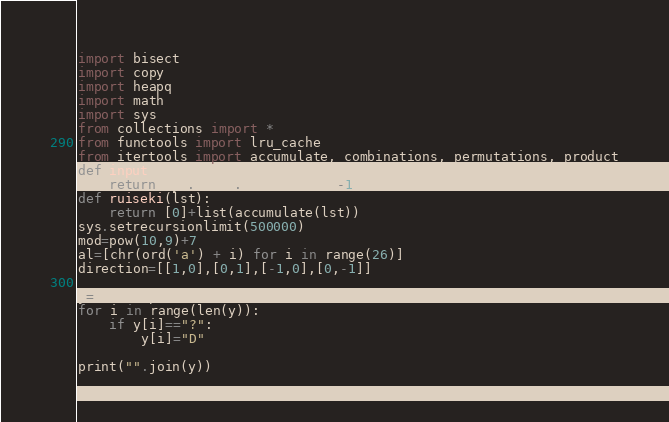<code> <loc_0><loc_0><loc_500><loc_500><_Python_>import bisect
import copy
import heapq
import math
import sys
from collections import *
from functools import lru_cache
from itertools import accumulate, combinations, permutations, product
def input():
    return sys.stdin.readline()[:-1]
def ruiseki(lst):
    return [0]+list(accumulate(lst))
sys.setrecursionlimit(500000)
mod=pow(10,9)+7
al=[chr(ord('a') + i) for i in range(26)]
direction=[[1,0],[0,1],[-1,0],[0,-1]]

y=list(input())
for i in range(len(y)):
    if y[i]=="?":
        y[i]="D"

print("".join(y))</code> 